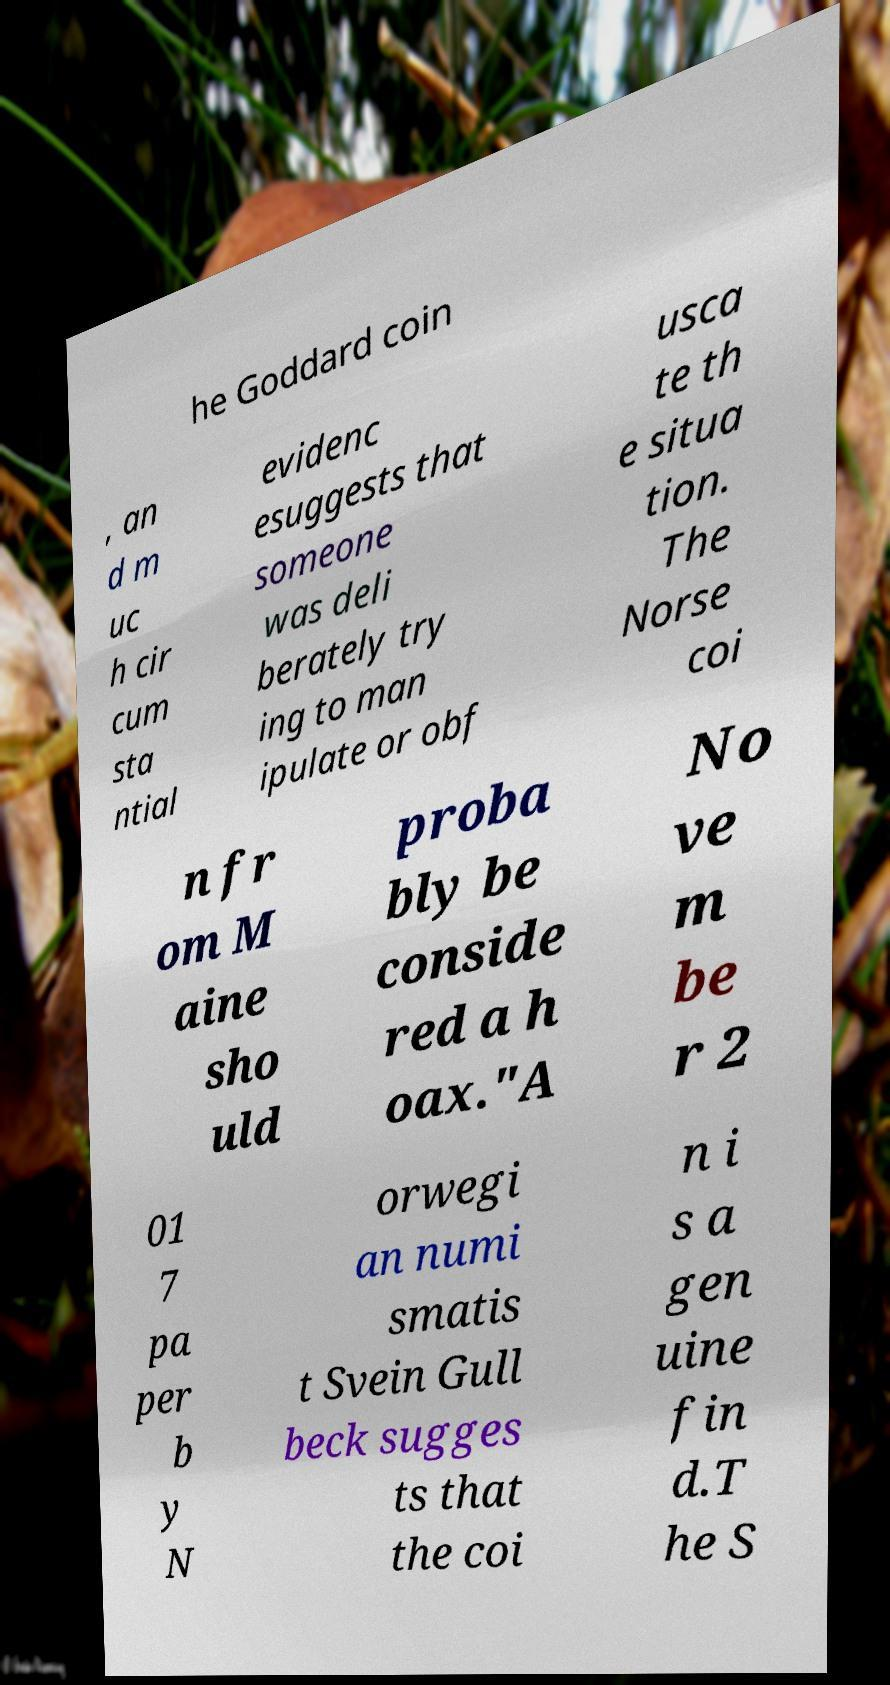Can you read and provide the text displayed in the image?This photo seems to have some interesting text. Can you extract and type it out for me? he Goddard coin , an d m uc h cir cum sta ntial evidenc esuggests that someone was deli berately try ing to man ipulate or obf usca te th e situa tion. The Norse coi n fr om M aine sho uld proba bly be conside red a h oax."A No ve m be r 2 01 7 pa per b y N orwegi an numi smatis t Svein Gull beck sugges ts that the coi n i s a gen uine fin d.T he S 